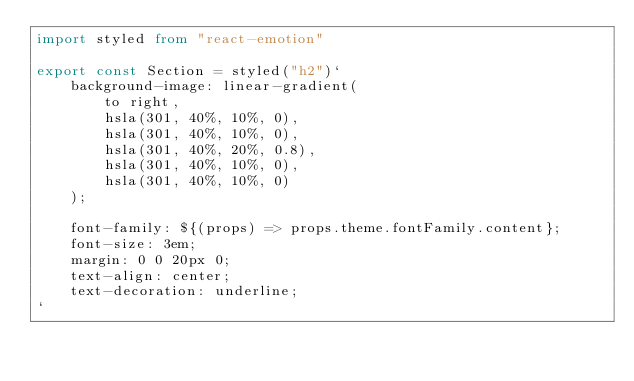Convert code to text. <code><loc_0><loc_0><loc_500><loc_500><_TypeScript_>import styled from "react-emotion"

export const Section = styled("h2")`
    background-image: linear-gradient(
        to right,
        hsla(301, 40%, 10%, 0),
        hsla(301, 40%, 10%, 0),
        hsla(301, 40%, 20%, 0.8),
        hsla(301, 40%, 10%, 0),
        hsla(301, 40%, 10%, 0)
    );

    font-family: ${(props) => props.theme.fontFamily.content};
    font-size: 3em;
    margin: 0 0 20px 0;
    text-align: center;
    text-decoration: underline;
`
</code> 